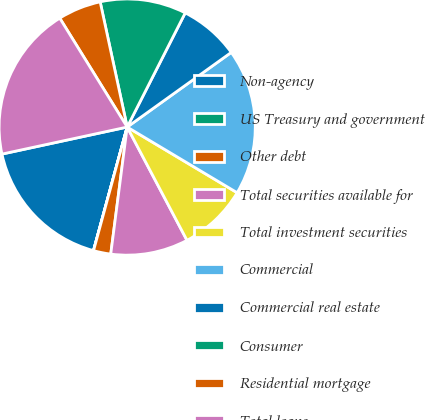<chart> <loc_0><loc_0><loc_500><loc_500><pie_chart><fcel>Non-agency<fcel>US Treasury and government<fcel>Other debt<fcel>Total securities available for<fcel>Total investment securities<fcel>Commercial<fcel>Commercial real estate<fcel>Consumer<fcel>Residential mortgage<fcel>Total loans<nl><fcel>17.38%<fcel>0.01%<fcel>2.18%<fcel>9.78%<fcel>8.7%<fcel>18.47%<fcel>7.61%<fcel>10.87%<fcel>5.44%<fcel>19.56%<nl></chart> 